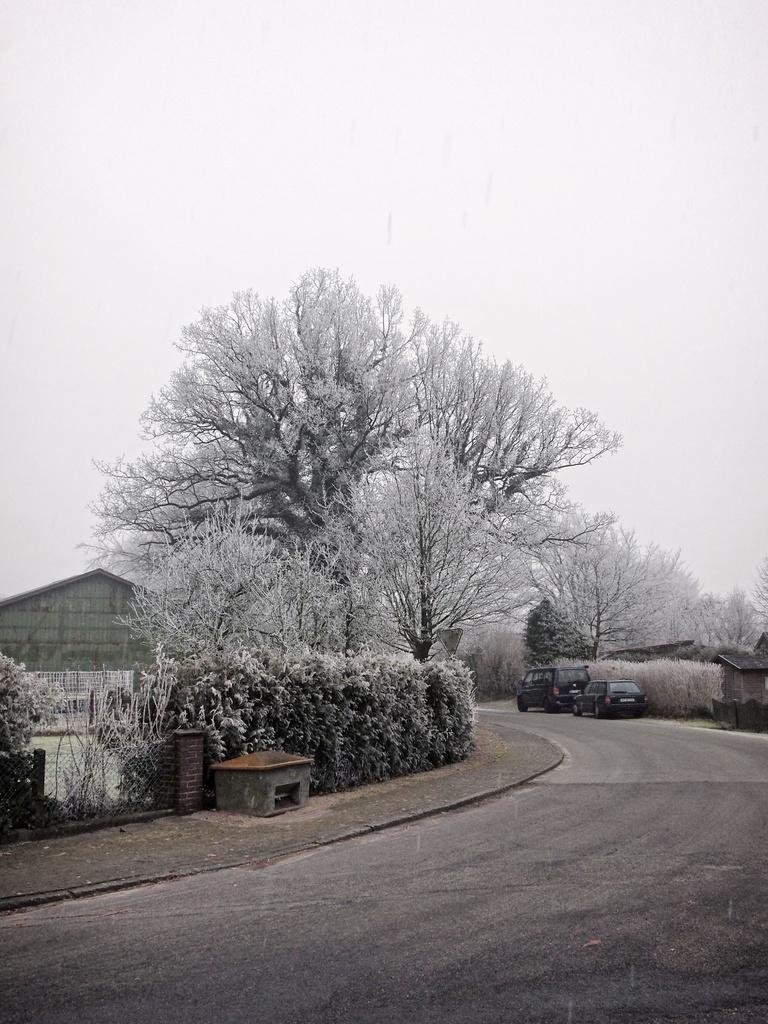What type of pathway is visible in the image? There is a road in the image. What can be seen alongside the road? There is a fence in the image. What type of vegetation is present in the image? There are plants and trees in the image. What type of structures are present in the image? Wooden houses are present in the image. What is the condition of the sky in the background of the image? The sky is visible in the background of the image, and it appears to be plain. What type of screw is being used to hold the writing in the image? There is no screw or writing present in the image. What type of operation is being performed on the trees in the image? There is no operation being performed on the trees in the image; they are simply standing in the background. 